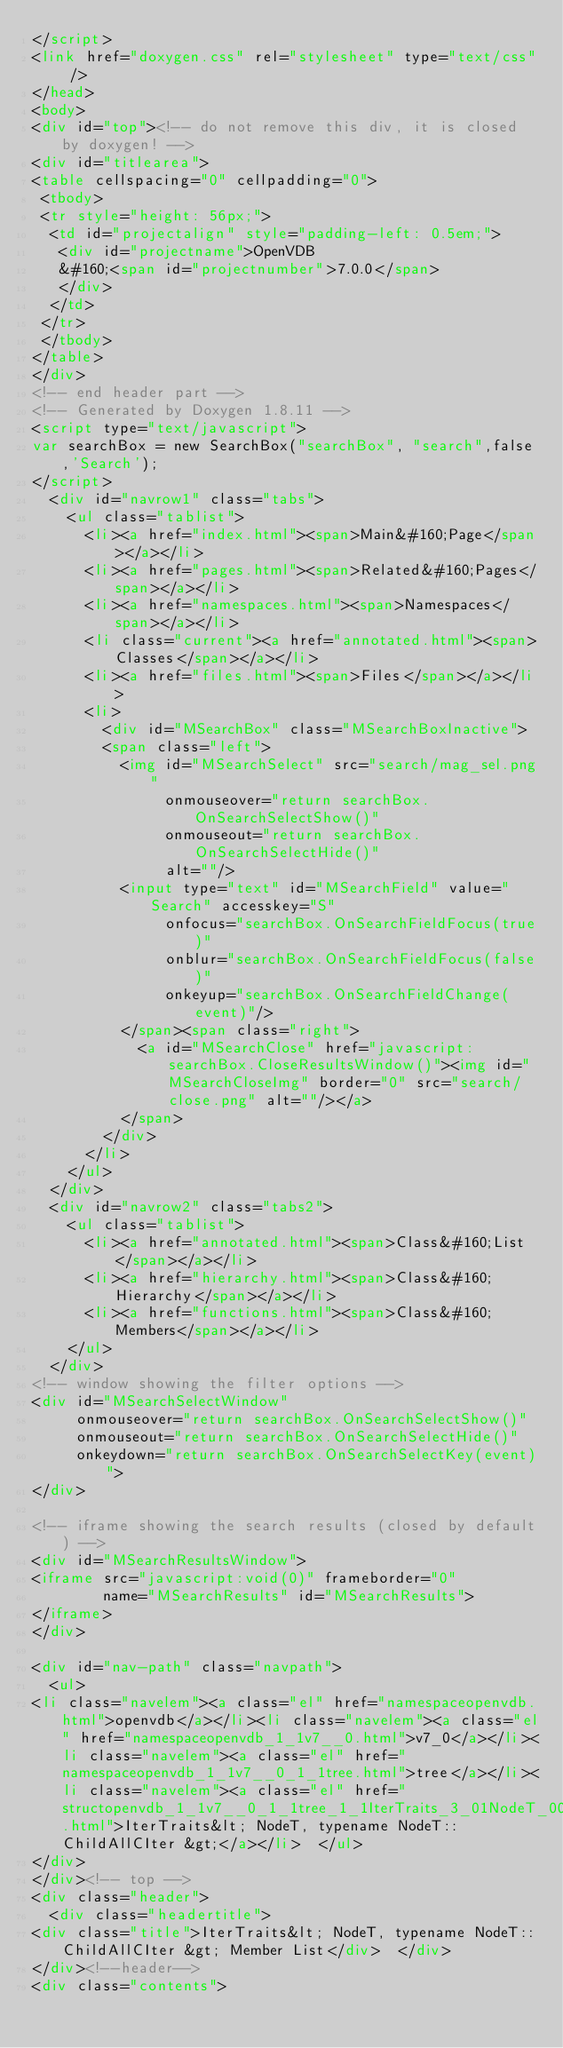Convert code to text. <code><loc_0><loc_0><loc_500><loc_500><_HTML_></script>
<link href="doxygen.css" rel="stylesheet" type="text/css" />
</head>
<body>
<div id="top"><!-- do not remove this div, it is closed by doxygen! -->
<div id="titlearea">
<table cellspacing="0" cellpadding="0">
 <tbody>
 <tr style="height: 56px;">
  <td id="projectalign" style="padding-left: 0.5em;">
   <div id="projectname">OpenVDB
   &#160;<span id="projectnumber">7.0.0</span>
   </div>
  </td>
 </tr>
 </tbody>
</table>
</div>
<!-- end header part -->
<!-- Generated by Doxygen 1.8.11 -->
<script type="text/javascript">
var searchBox = new SearchBox("searchBox", "search",false,'Search');
</script>
  <div id="navrow1" class="tabs">
    <ul class="tablist">
      <li><a href="index.html"><span>Main&#160;Page</span></a></li>
      <li><a href="pages.html"><span>Related&#160;Pages</span></a></li>
      <li><a href="namespaces.html"><span>Namespaces</span></a></li>
      <li class="current"><a href="annotated.html"><span>Classes</span></a></li>
      <li><a href="files.html"><span>Files</span></a></li>
      <li>
        <div id="MSearchBox" class="MSearchBoxInactive">
        <span class="left">
          <img id="MSearchSelect" src="search/mag_sel.png"
               onmouseover="return searchBox.OnSearchSelectShow()"
               onmouseout="return searchBox.OnSearchSelectHide()"
               alt=""/>
          <input type="text" id="MSearchField" value="Search" accesskey="S"
               onfocus="searchBox.OnSearchFieldFocus(true)" 
               onblur="searchBox.OnSearchFieldFocus(false)" 
               onkeyup="searchBox.OnSearchFieldChange(event)"/>
          </span><span class="right">
            <a id="MSearchClose" href="javascript:searchBox.CloseResultsWindow()"><img id="MSearchCloseImg" border="0" src="search/close.png" alt=""/></a>
          </span>
        </div>
      </li>
    </ul>
  </div>
  <div id="navrow2" class="tabs2">
    <ul class="tablist">
      <li><a href="annotated.html"><span>Class&#160;List</span></a></li>
      <li><a href="hierarchy.html"><span>Class&#160;Hierarchy</span></a></li>
      <li><a href="functions.html"><span>Class&#160;Members</span></a></li>
    </ul>
  </div>
<!-- window showing the filter options -->
<div id="MSearchSelectWindow"
     onmouseover="return searchBox.OnSearchSelectShow()"
     onmouseout="return searchBox.OnSearchSelectHide()"
     onkeydown="return searchBox.OnSearchSelectKey(event)">
</div>

<!-- iframe showing the search results (closed by default) -->
<div id="MSearchResultsWindow">
<iframe src="javascript:void(0)" frameborder="0" 
        name="MSearchResults" id="MSearchResults">
</iframe>
</div>

<div id="nav-path" class="navpath">
  <ul>
<li class="navelem"><a class="el" href="namespaceopenvdb.html">openvdb</a></li><li class="navelem"><a class="el" href="namespaceopenvdb_1_1v7__0.html">v7_0</a></li><li class="navelem"><a class="el" href="namespaceopenvdb_1_1v7__0_1_1tree.html">tree</a></li><li class="navelem"><a class="el" href="structopenvdb_1_1v7__0_1_1tree_1_1IterTraits_3_01NodeT_00_01typename_01NodeT_1_1ChildAllCIter_01_4.html">IterTraits&lt; NodeT, typename NodeT::ChildAllCIter &gt;</a></li>  </ul>
</div>
</div><!-- top -->
<div class="header">
  <div class="headertitle">
<div class="title">IterTraits&lt; NodeT, typename NodeT::ChildAllCIter &gt; Member List</div>  </div>
</div><!--header-->
<div class="contents">
</code> 